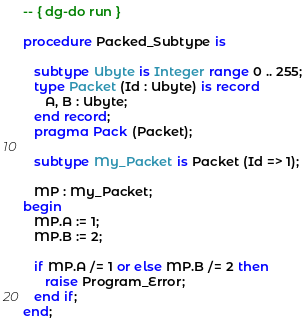Convert code to text. <code><loc_0><loc_0><loc_500><loc_500><_Ada_>-- { dg-do run }

procedure Packed_Subtype is

   subtype Ubyte is Integer range 0 .. 255;
   type Packet (Id : Ubyte) is record
      A, B : Ubyte;
   end record;
   pragma Pack (Packet);

   subtype My_Packet is Packet (Id => 1);

   MP : My_Packet;
begin
   MP.A := 1;
   MP.B := 2;

   if MP.A /= 1 or else MP.B /= 2 then
      raise Program_Error;
   end if;
end;



</code> 